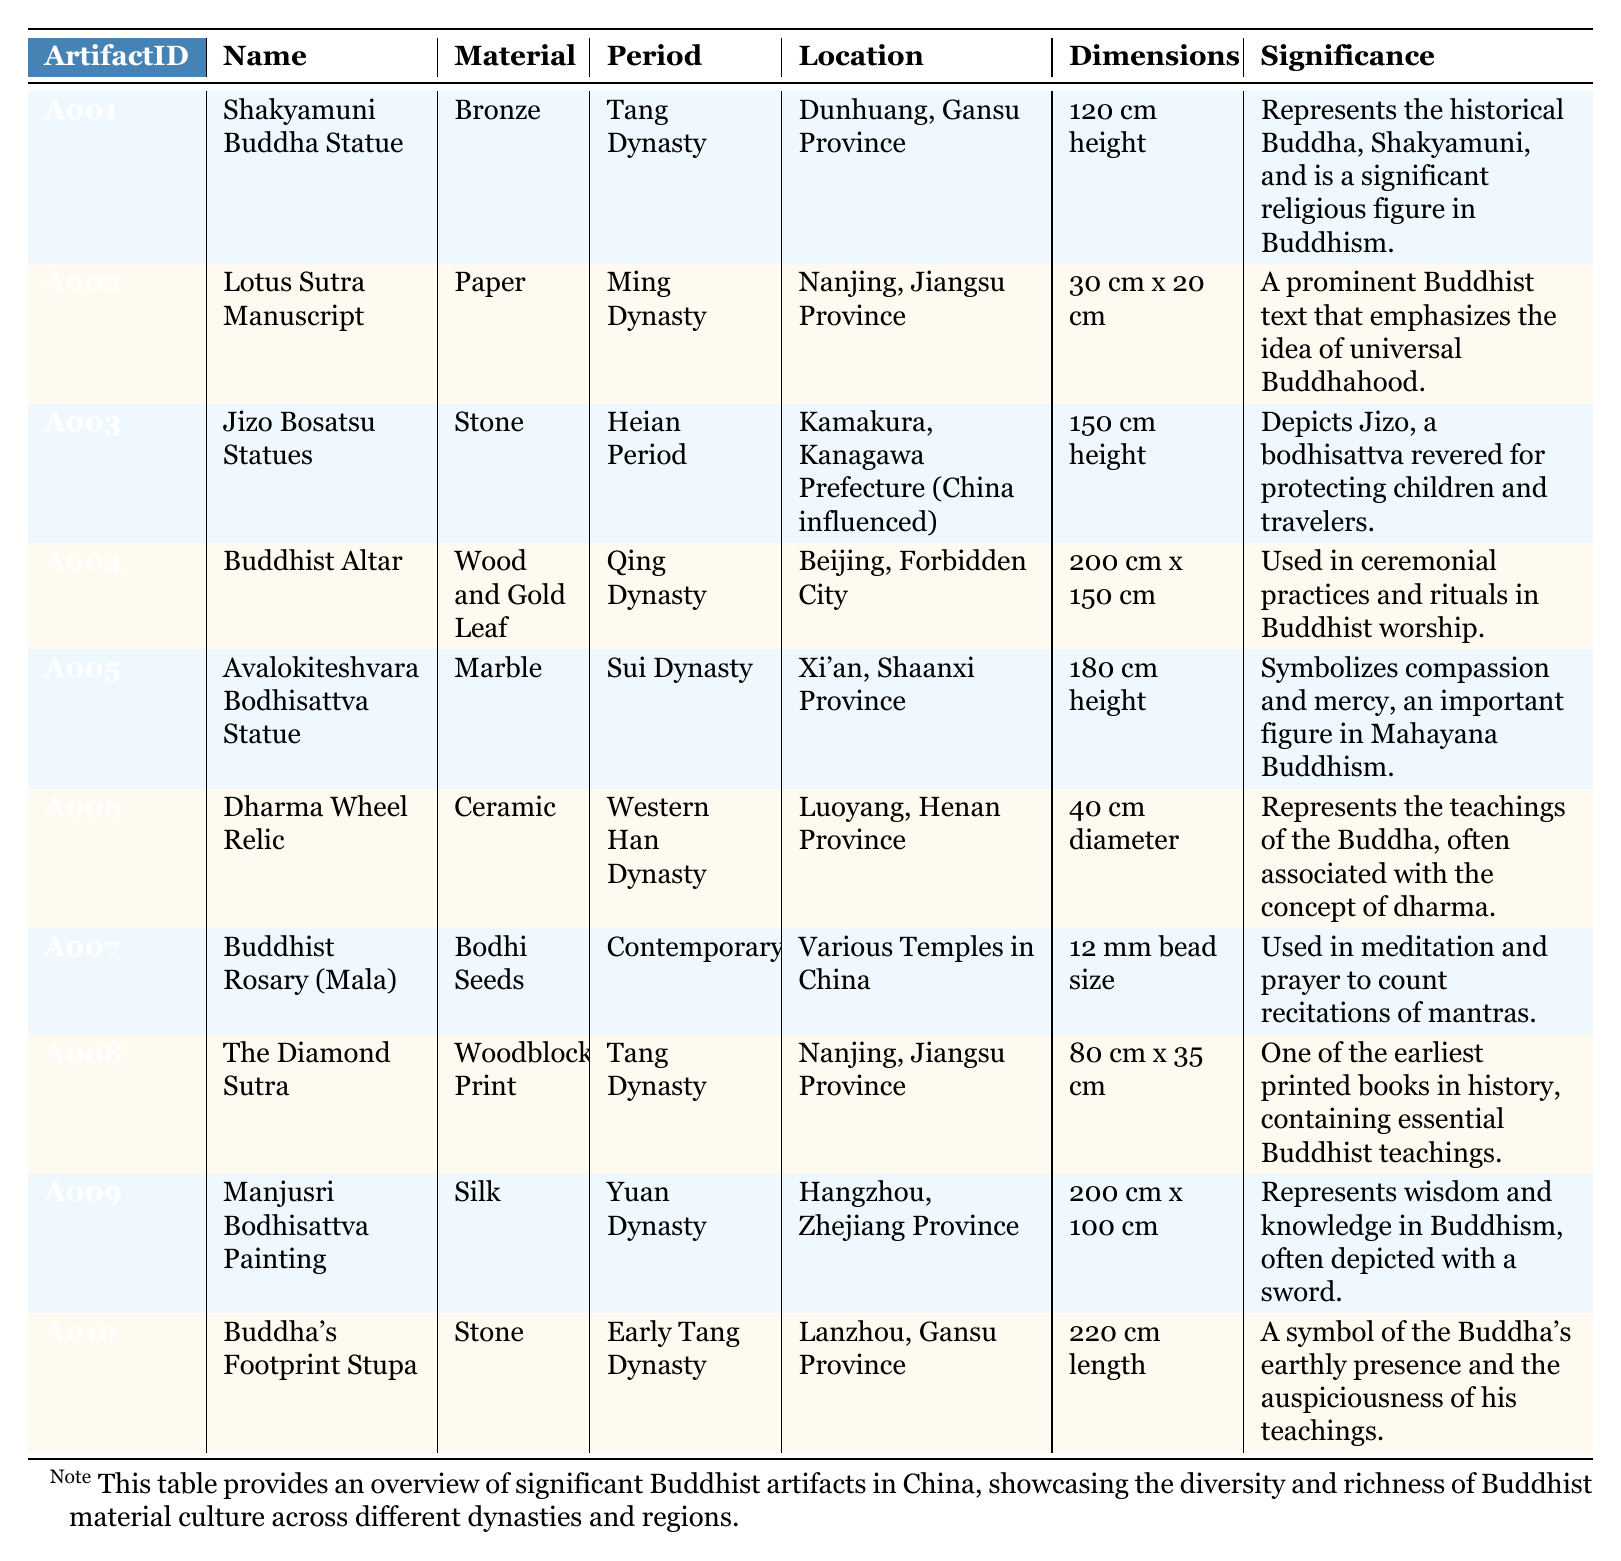What is the material of the Shakyamuni Buddha Statue? The table states that the material of the Shakyamuni Buddha Statue is bronze.
Answer: Bronze Which artifact has the largest dimensions? By comparing the dimensions listed in the table, the Buddha's Footprint Stupa measures 220 cm in length, which is larger than any other artifact's dimensions.
Answer: Buddha's Footprint Stupa Is the Lotus Sutra Manuscript older than the Dharma Wheel Relic? The Lotus Sutra Manuscript is from the Ming Dynasty, while the Dharma Wheel Relic is from the Western Han Dynasty, which is earlier. Therefore, the statement is false.
Answer: No Count how many artifacts are made of stone. There are three artifacts made of stone: Jizo Bosatsu Statues, Buddha's Footprint Stupa, and Avalokiteshvara Bodhisattva Statue.
Answer: Three What is the significance of the Avalokiteshvara Bodhisattva Statue? The table explains that the Avalokiteshvara Bodhisattva Statue symbolizes compassion and mercy, which are important aspects of Mahayana Buddhism.
Answer: Symbolizes compassion and mercy Which period has the most artifacts listed? By analyzing the periods in the table, each of them is unique, thus no single period has more than one artifact listed.
Answer: None How many artifacts are from the Tang Dynasty? There are two artifacts from the Tang Dynasty: Shakyamuni Buddha Statue and The Diamond Sutra.
Answer: Two If I combine the heights of the Shakyamuni Buddha Statue and the Avalokiteshvara Bodhisattva Statue, what will be the total height? The heights are 120 cm and 180 cm respectively. Adding them together gives 120 cm + 180 cm = 300 cm total height.
Answer: 300 cm Which artifact's significance includes reference to children's protection? The Jizo Bosatsu Statues are noted for depicting Jizo, a bodhisattva revered for protecting children and travelers.
Answer: Jizo Bosatsu Statues True or False: The Diamond Sutra is printed on paper. The table indicates that The Diamond Sutra is a woodblock print, which means the statement is false.
Answer: False 